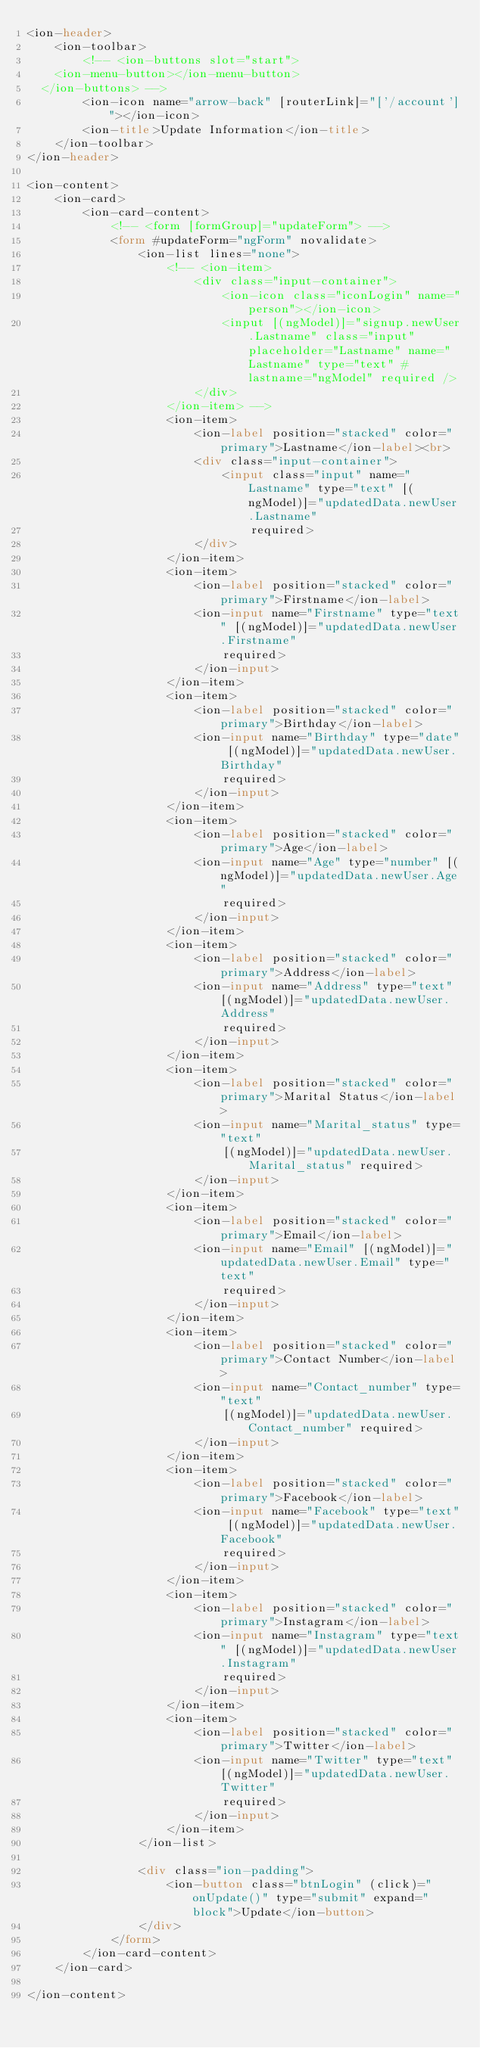<code> <loc_0><loc_0><loc_500><loc_500><_HTML_><ion-header>
    <ion-toolbar>
        <!-- <ion-buttons slot="start">
    <ion-menu-button></ion-menu-button>
  </ion-buttons> -->
        <ion-icon name="arrow-back" [routerLink]="['/account']"></ion-icon>
        <ion-title>Update Information</ion-title>
    </ion-toolbar>
</ion-header>

<ion-content>
    <ion-card>
        <ion-card-content>
            <!-- <form [formGroup]="updateForm"> -->
            <form #updateForm="ngForm" novalidate>
                <ion-list lines="none">
                    <!-- <ion-item>
                        <div class="input-container">
                            <ion-icon class="iconLogin" name="person"></ion-icon>
                            <input [(ngModel)]="signup.newUser.Lastname" class="input" placeholder="Lastname" name="Lastname" type="text" #lastname="ngModel" required />
                        </div>
                    </ion-item> -->
                    <ion-item>
                        <ion-label position="stacked" color="primary">Lastname</ion-label><br>
                        <div class="input-container">
                            <input class="input" name="Lastname" type="text" [(ngModel)]="updatedData.newUser.Lastname"
                                required>
                        </div>
                    </ion-item>
                    <ion-item>
                        <ion-label position="stacked" color="primary">Firstname</ion-label>
                        <ion-input name="Firstname" type="text" [(ngModel)]="updatedData.newUser.Firstname"
                            required>
                        </ion-input>
                    </ion-item>
                    <ion-item>
                        <ion-label position="stacked" color="primary">Birthday</ion-label>
                        <ion-input name="Birthday" type="date" [(ngModel)]="updatedData.newUser.Birthday"
                            required>
                        </ion-input>
                    </ion-item>
                    <ion-item>
                        <ion-label position="stacked" color="primary">Age</ion-label>
                        <ion-input name="Age" type="number" [(ngModel)]="updatedData.newUser.Age"
                            required>
                        </ion-input>
                    </ion-item>
                    <ion-item>
                        <ion-label position="stacked" color="primary">Address</ion-label>
                        <ion-input name="Address" type="text" [(ngModel)]="updatedData.newUser.Address"
                            required>
                        </ion-input>
                    </ion-item>
                    <ion-item>
                        <ion-label position="stacked" color="primary">Marital Status</ion-label>
                        <ion-input name="Marital_status" type="text"
                            [(ngModel)]="updatedData.newUser.Marital_status" required>
                        </ion-input>
                    </ion-item>
                    <ion-item>
                        <ion-label position="stacked" color="primary">Email</ion-label>
                        <ion-input name="Email" [(ngModel)]="updatedData.newUser.Email" type="text"
                            required>
                        </ion-input>
                    </ion-item>
                    <ion-item>
                        <ion-label position="stacked" color="primary">Contact Number</ion-label>
                        <ion-input name="Contact_number" type="text"
                            [(ngModel)]="updatedData.newUser.Contact_number" required>
                        </ion-input>
                    </ion-item>
                    <ion-item>
                        <ion-label position="stacked" color="primary">Facebook</ion-label>
                        <ion-input name="Facebook" type="text" [(ngModel)]="updatedData.newUser.Facebook"
                            required>
                        </ion-input>
                    </ion-item>
                    <ion-item>
                        <ion-label position="stacked" color="primary">Instagram</ion-label>
                        <ion-input name="Instagram" type="text" [(ngModel)]="updatedData.newUser.Instagram"
                            required>
                        </ion-input>
                    </ion-item>
                    <ion-item>
                        <ion-label position="stacked" color="primary">Twitter</ion-label>
                        <ion-input name="Twitter" type="text" [(ngModel)]="updatedData.newUser.Twitter"
                            required>
                        </ion-input>
                    </ion-item>
                </ion-list>

                <div class="ion-padding">
                    <ion-button class="btnLogin" (click)="onUpdate()" type="submit" expand="block">Update</ion-button>
                </div>
            </form>
        </ion-card-content>
    </ion-card>

</ion-content></code> 